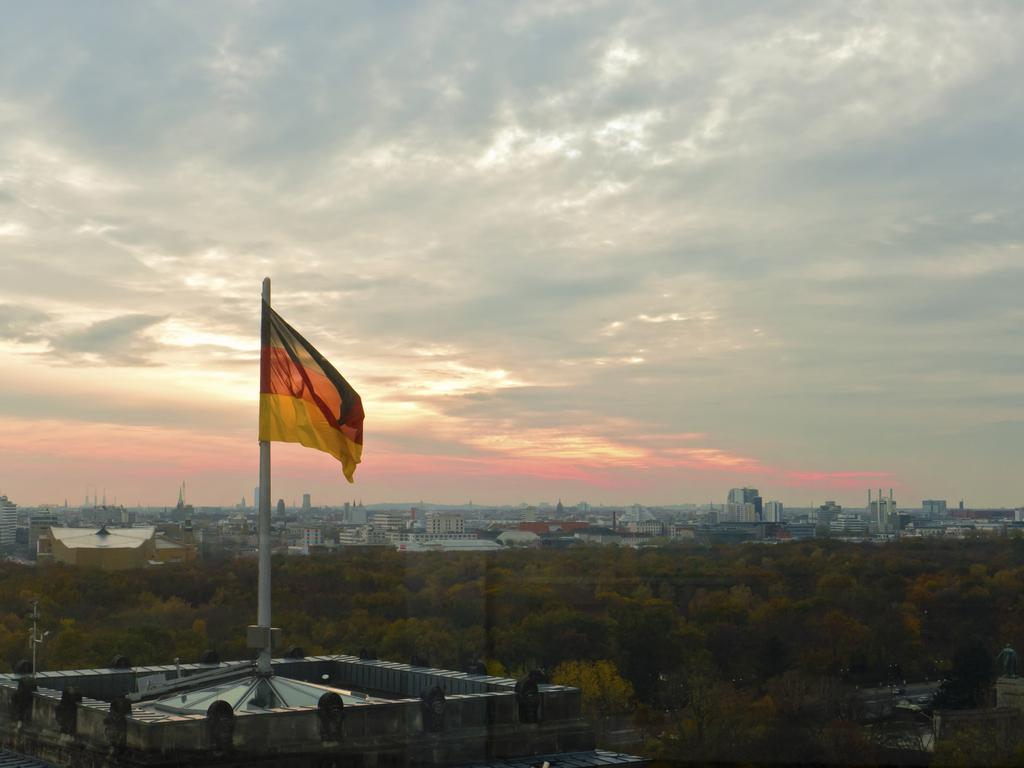What can be seen flying or waving in the image? There is a flag in the image. What type of natural elements are present in the image? There are trees in the image. What type of man-made structures can be seen in the image? There are buildings in the image. What is visible in the background of the image? The sky is visible in the background of the image. What type of linen is being used to cover the watch in the image? There is no watch or linen present in the image. How does the flag move around in the image? The flag does not move around in the image; it is stationary. 